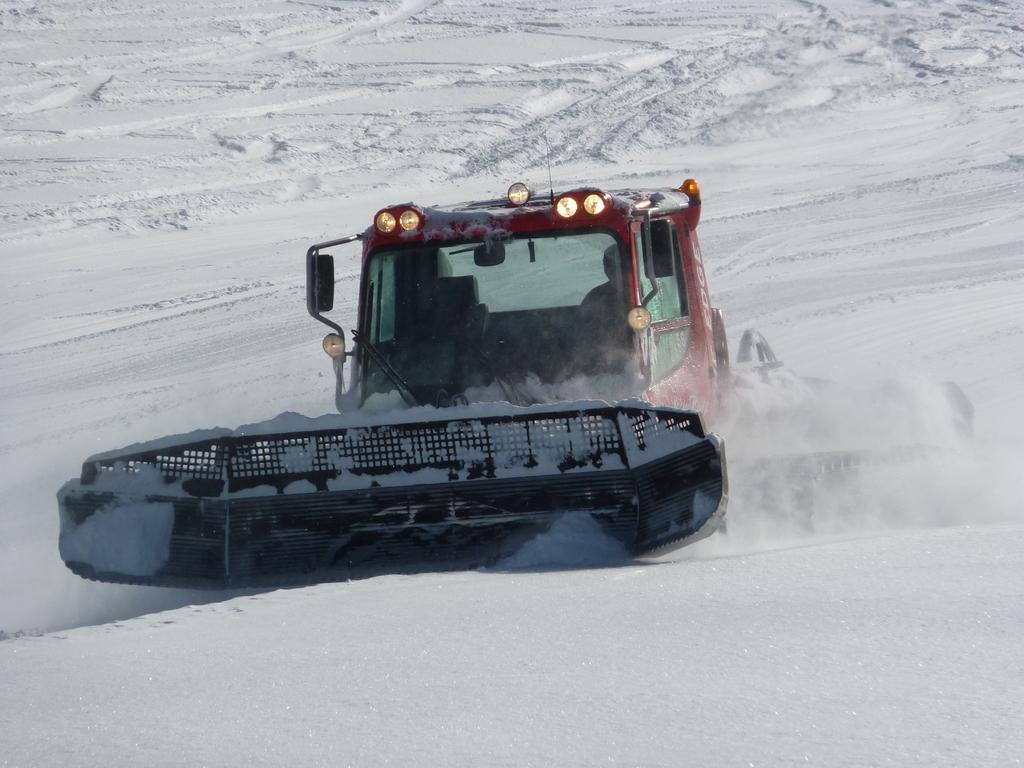Can you describe this image briefly? In this image we can see a person sitting inside a vehicle placed on the snow. 